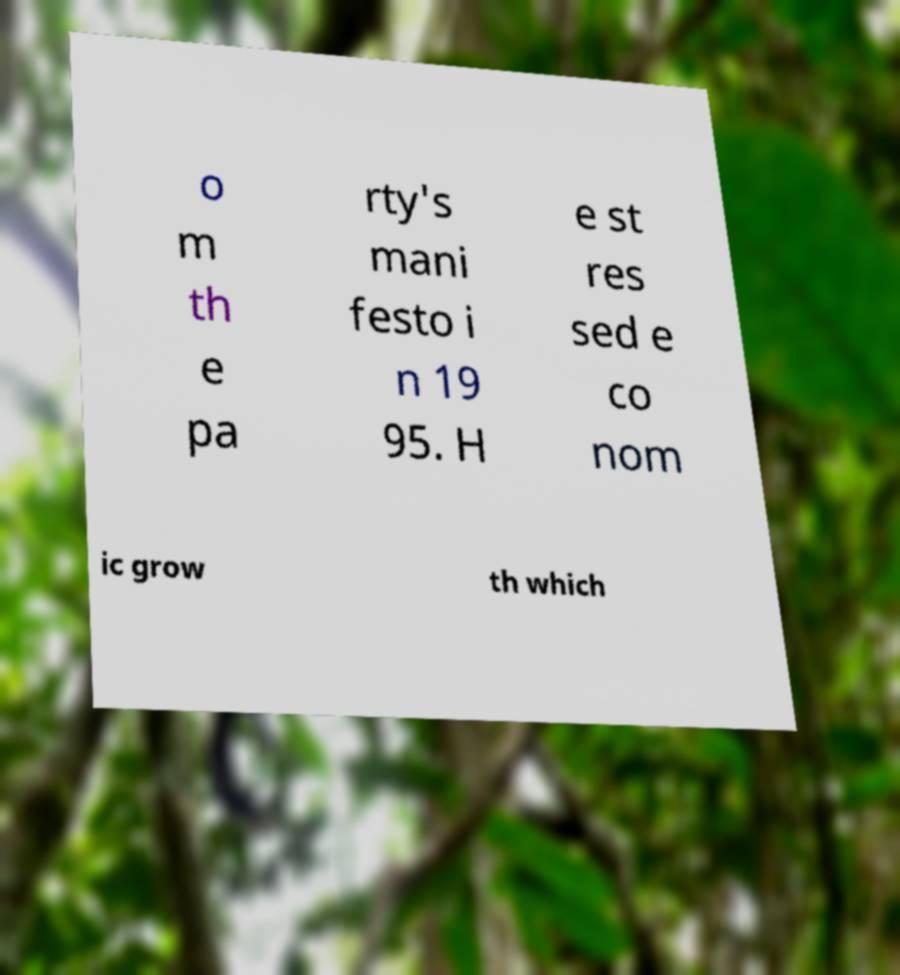There's text embedded in this image that I need extracted. Can you transcribe it verbatim? o m th e pa rty's mani festo i n 19 95. H e st res sed e co nom ic grow th which 